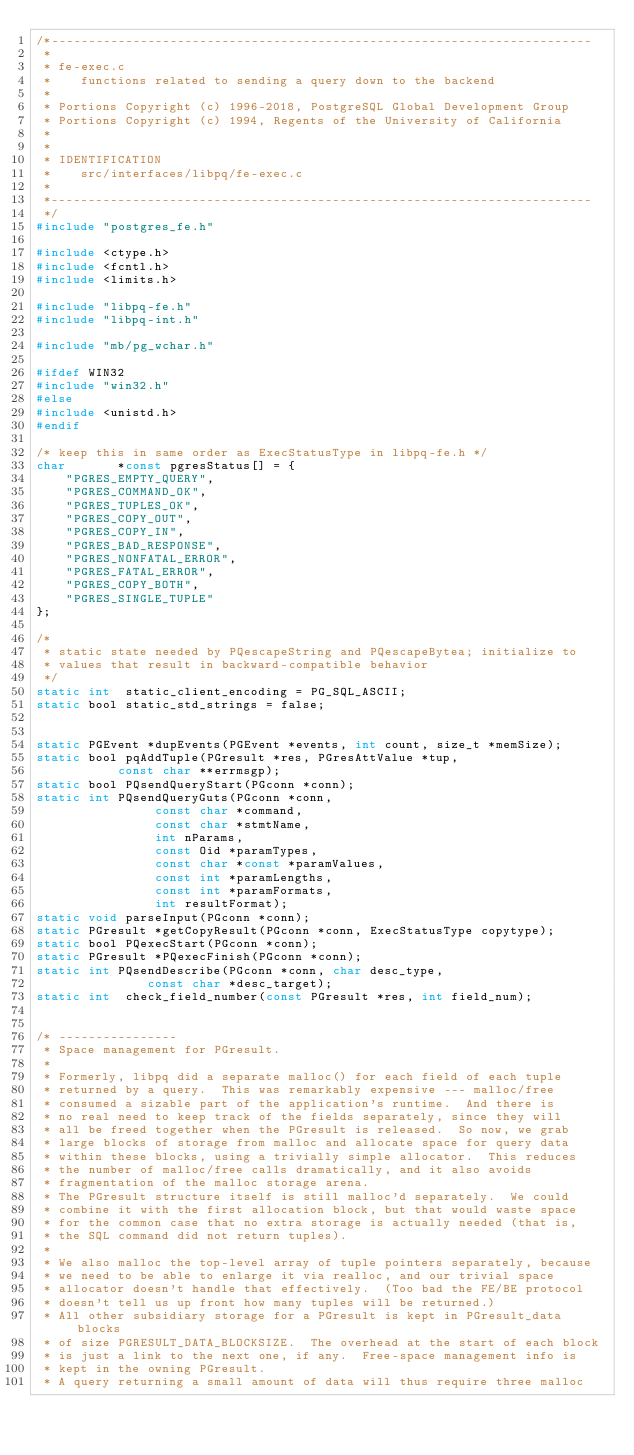Convert code to text. <code><loc_0><loc_0><loc_500><loc_500><_C_>/*-------------------------------------------------------------------------
 *
 * fe-exec.c
 *	  functions related to sending a query down to the backend
 *
 * Portions Copyright (c) 1996-2018, PostgreSQL Global Development Group
 * Portions Copyright (c) 1994, Regents of the University of California
 *
 *
 * IDENTIFICATION
 *	  src/interfaces/libpq/fe-exec.c
 *
 *-------------------------------------------------------------------------
 */
#include "postgres_fe.h"

#include <ctype.h>
#include <fcntl.h>
#include <limits.h>

#include "libpq-fe.h"
#include "libpq-int.h"

#include "mb/pg_wchar.h"

#ifdef WIN32
#include "win32.h"
#else
#include <unistd.h>
#endif

/* keep this in same order as ExecStatusType in libpq-fe.h */
char	   *const pgresStatus[] = {
	"PGRES_EMPTY_QUERY",
	"PGRES_COMMAND_OK",
	"PGRES_TUPLES_OK",
	"PGRES_COPY_OUT",
	"PGRES_COPY_IN",
	"PGRES_BAD_RESPONSE",
	"PGRES_NONFATAL_ERROR",
	"PGRES_FATAL_ERROR",
	"PGRES_COPY_BOTH",
	"PGRES_SINGLE_TUPLE"
};

/*
 * static state needed by PQescapeString and PQescapeBytea; initialize to
 * values that result in backward-compatible behavior
 */
static int	static_client_encoding = PG_SQL_ASCII;
static bool static_std_strings = false;


static PGEvent *dupEvents(PGEvent *events, int count, size_t *memSize);
static bool pqAddTuple(PGresult *res, PGresAttValue *tup,
		   const char **errmsgp);
static bool PQsendQueryStart(PGconn *conn);
static int PQsendQueryGuts(PGconn *conn,
				const char *command,
				const char *stmtName,
				int nParams,
				const Oid *paramTypes,
				const char *const *paramValues,
				const int *paramLengths,
				const int *paramFormats,
				int resultFormat);
static void parseInput(PGconn *conn);
static PGresult *getCopyResult(PGconn *conn, ExecStatusType copytype);
static bool PQexecStart(PGconn *conn);
static PGresult *PQexecFinish(PGconn *conn);
static int PQsendDescribe(PGconn *conn, char desc_type,
			   const char *desc_target);
static int	check_field_number(const PGresult *res, int field_num);


/* ----------------
 * Space management for PGresult.
 *
 * Formerly, libpq did a separate malloc() for each field of each tuple
 * returned by a query.  This was remarkably expensive --- malloc/free
 * consumed a sizable part of the application's runtime.  And there is
 * no real need to keep track of the fields separately, since they will
 * all be freed together when the PGresult is released.  So now, we grab
 * large blocks of storage from malloc and allocate space for query data
 * within these blocks, using a trivially simple allocator.  This reduces
 * the number of malloc/free calls dramatically, and it also avoids
 * fragmentation of the malloc storage arena.
 * The PGresult structure itself is still malloc'd separately.  We could
 * combine it with the first allocation block, but that would waste space
 * for the common case that no extra storage is actually needed (that is,
 * the SQL command did not return tuples).
 *
 * We also malloc the top-level array of tuple pointers separately, because
 * we need to be able to enlarge it via realloc, and our trivial space
 * allocator doesn't handle that effectively.  (Too bad the FE/BE protocol
 * doesn't tell us up front how many tuples will be returned.)
 * All other subsidiary storage for a PGresult is kept in PGresult_data blocks
 * of size PGRESULT_DATA_BLOCKSIZE.  The overhead at the start of each block
 * is just a link to the next one, if any.  Free-space management info is
 * kept in the owning PGresult.
 * A query returning a small amount of data will thus require three malloc</code> 